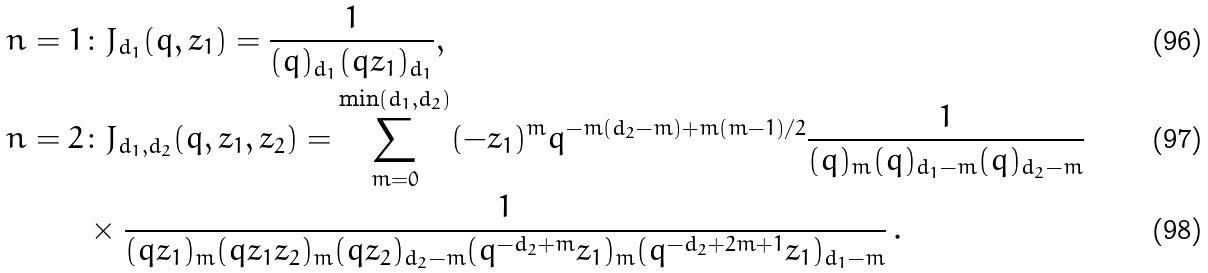Convert formula to latex. <formula><loc_0><loc_0><loc_500><loc_500>n = 1 & \colon J _ { d _ { 1 } } ( q , z _ { 1 } ) = \frac { 1 } { ( q ) _ { d _ { 1 } } ( q z _ { 1 } ) _ { d _ { 1 } } } , \\ n = 2 & \colon J _ { d _ { 1 } , d _ { 2 } } ( q , z _ { 1 } , z _ { 2 } ) = \sum _ { m = 0 } ^ { \min ( d _ { 1 } , d _ { 2 } ) } ( - z _ { 1 } ) ^ { m } q ^ { - m ( d _ { 2 } - m ) + m ( m - 1 ) / 2 } \frac { 1 } { ( q ) _ { m } ( q ) _ { d _ { 1 } - m } ( q ) _ { d _ { 2 } - m } } \\ & \times \frac { 1 } { ( q z _ { 1 } ) _ { m } ( q z _ { 1 } z _ { 2 } ) _ { m } ( q z _ { 2 } ) _ { d _ { 2 } - m } ( q ^ { - d _ { 2 } + m } z _ { 1 } ) _ { m } ( q ^ { - d _ { 2 } + 2 m + 1 } z _ { 1 } ) _ { d _ { 1 } - m } } \, .</formula> 